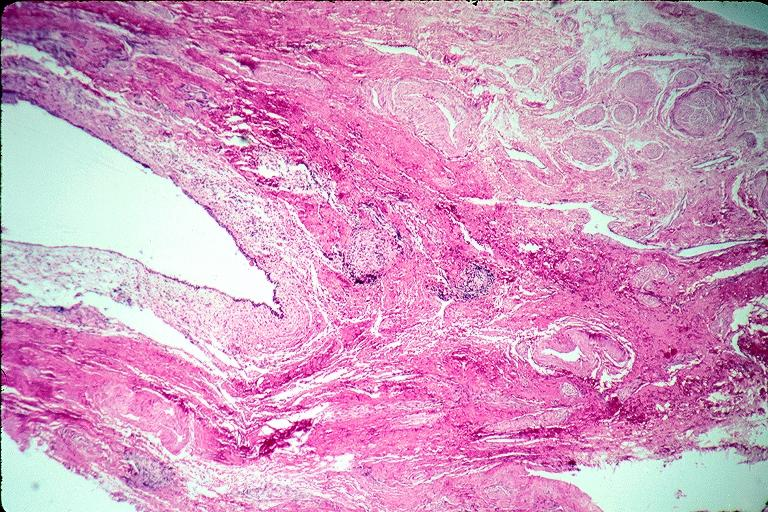does this image show incisive canal cyst nasopalatien duct cyst?
Answer the question using a single word or phrase. Yes 